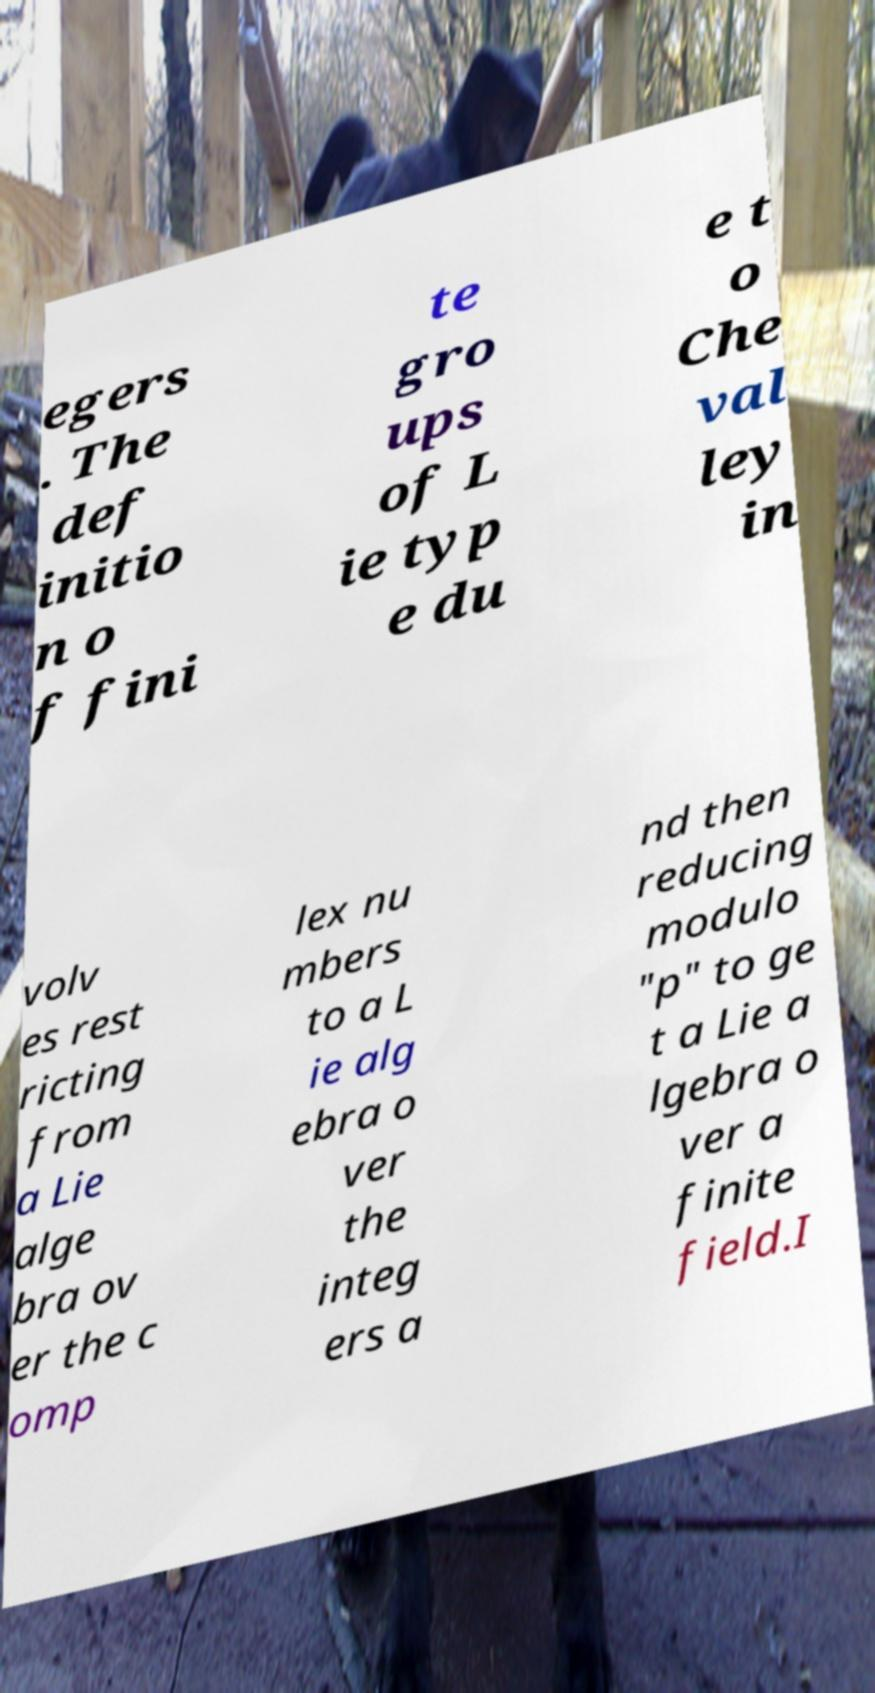Could you extract and type out the text from this image? egers . The def initio n o f fini te gro ups of L ie typ e du e t o Che val ley in volv es rest ricting from a Lie alge bra ov er the c omp lex nu mbers to a L ie alg ebra o ver the integ ers a nd then reducing modulo "p" to ge t a Lie a lgebra o ver a finite field.I 